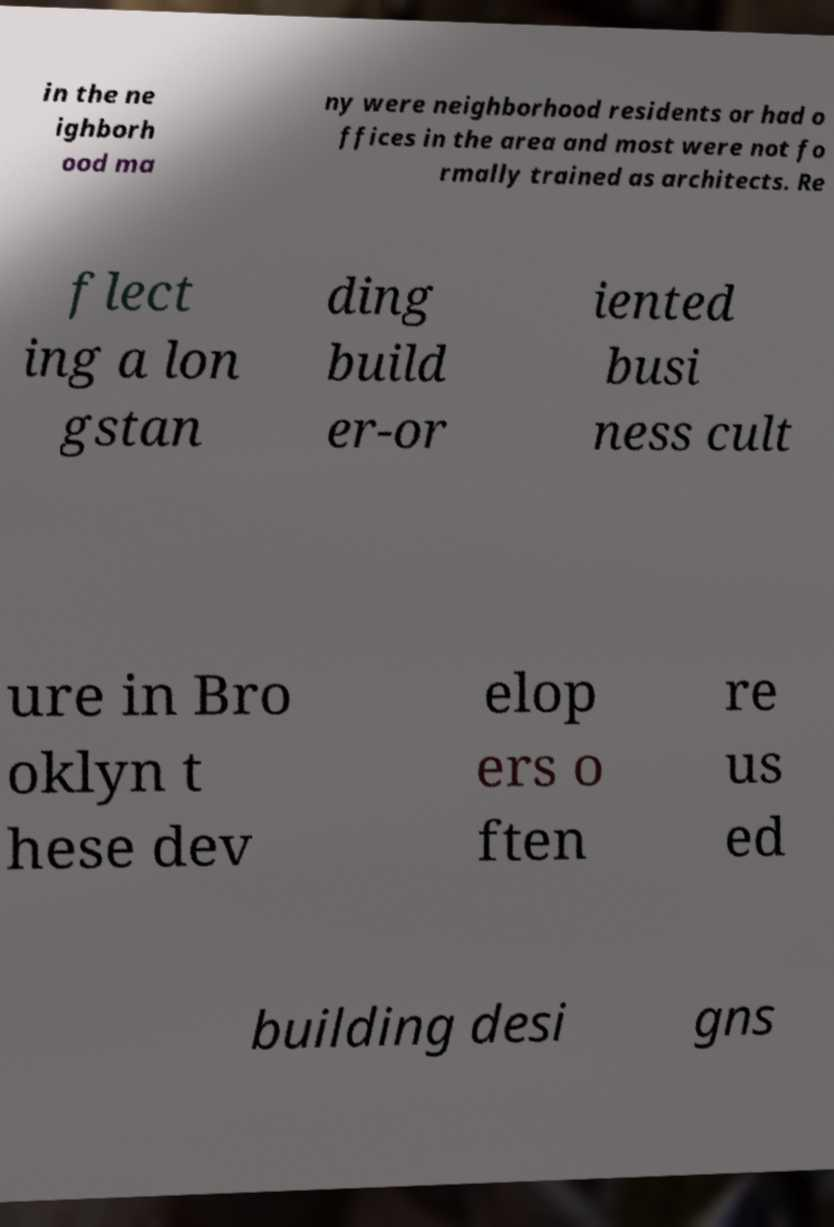What messages or text are displayed in this image? I need them in a readable, typed format. in the ne ighborh ood ma ny were neighborhood residents or had o ffices in the area and most were not fo rmally trained as architects. Re flect ing a lon gstan ding build er-or iented busi ness cult ure in Bro oklyn t hese dev elop ers o ften re us ed building desi gns 